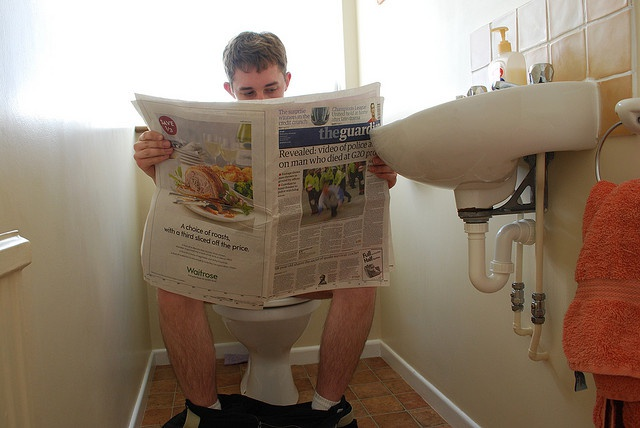Describe the objects in this image and their specific colors. I can see sink in lightgray, gray, and darkgray tones, people in lightgray, maroon, gray, and brown tones, toilet in lightgray, black, and gray tones, and bottle in lightgray, white, and tan tones in this image. 